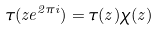<formula> <loc_0><loc_0><loc_500><loc_500>\tau ( z e ^ { 2 \pi i } ) = \tau ( z ) \chi ( z )</formula> 